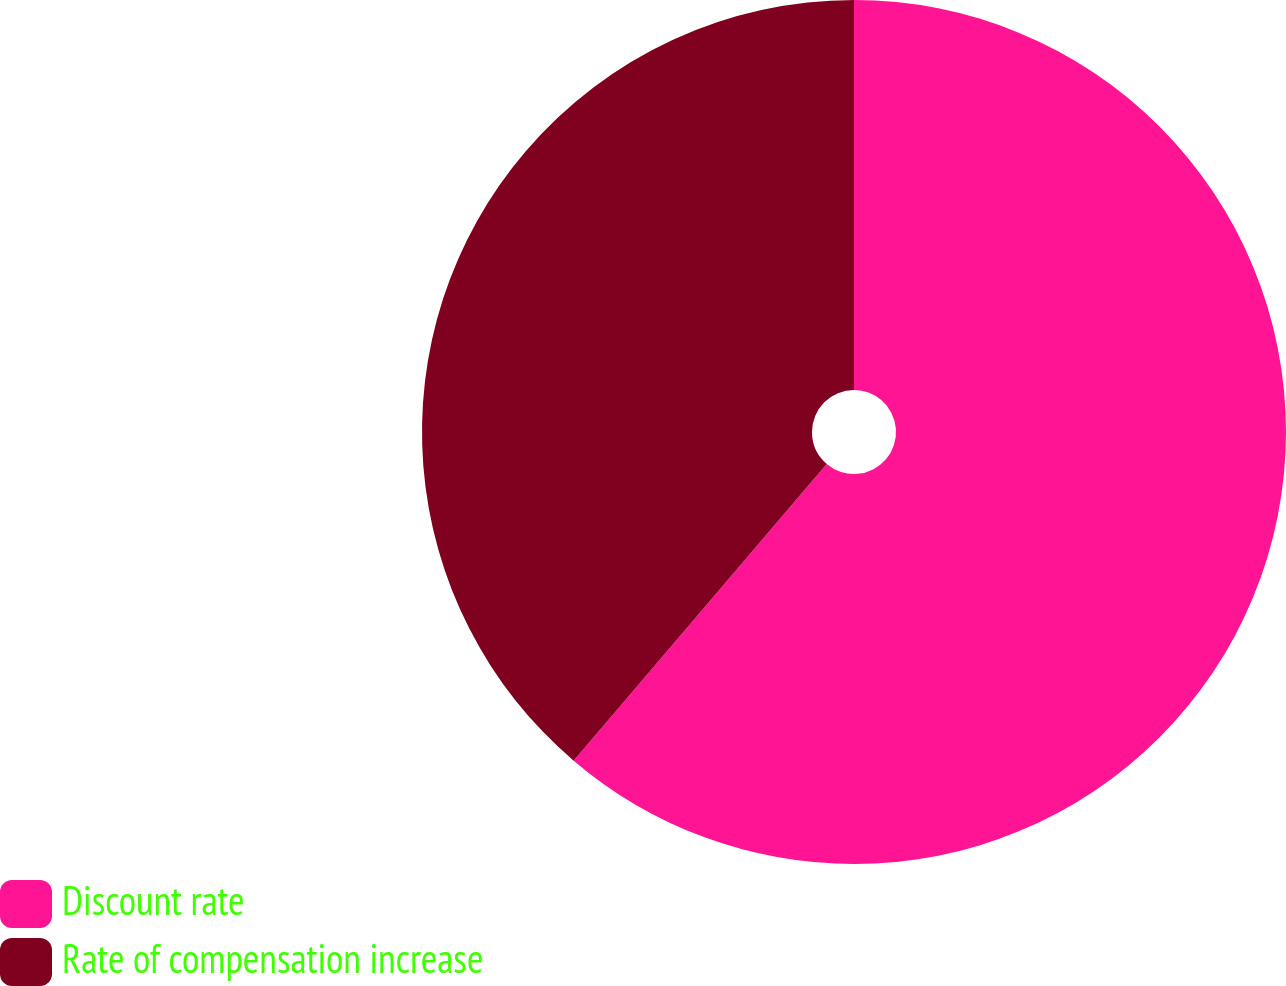Convert chart. <chart><loc_0><loc_0><loc_500><loc_500><pie_chart><fcel>Discount rate<fcel>Rate of compensation increase<nl><fcel>61.24%<fcel>38.76%<nl></chart> 